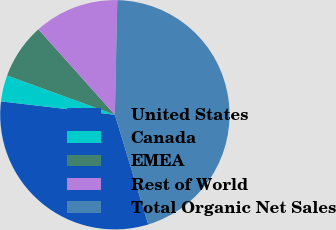<chart> <loc_0><loc_0><loc_500><loc_500><pie_chart><fcel>United States<fcel>Canada<fcel>EMEA<fcel>Rest of World<fcel>Total Organic Net Sales<nl><fcel>31.57%<fcel>3.7%<fcel>7.82%<fcel>11.95%<fcel>44.96%<nl></chart> 